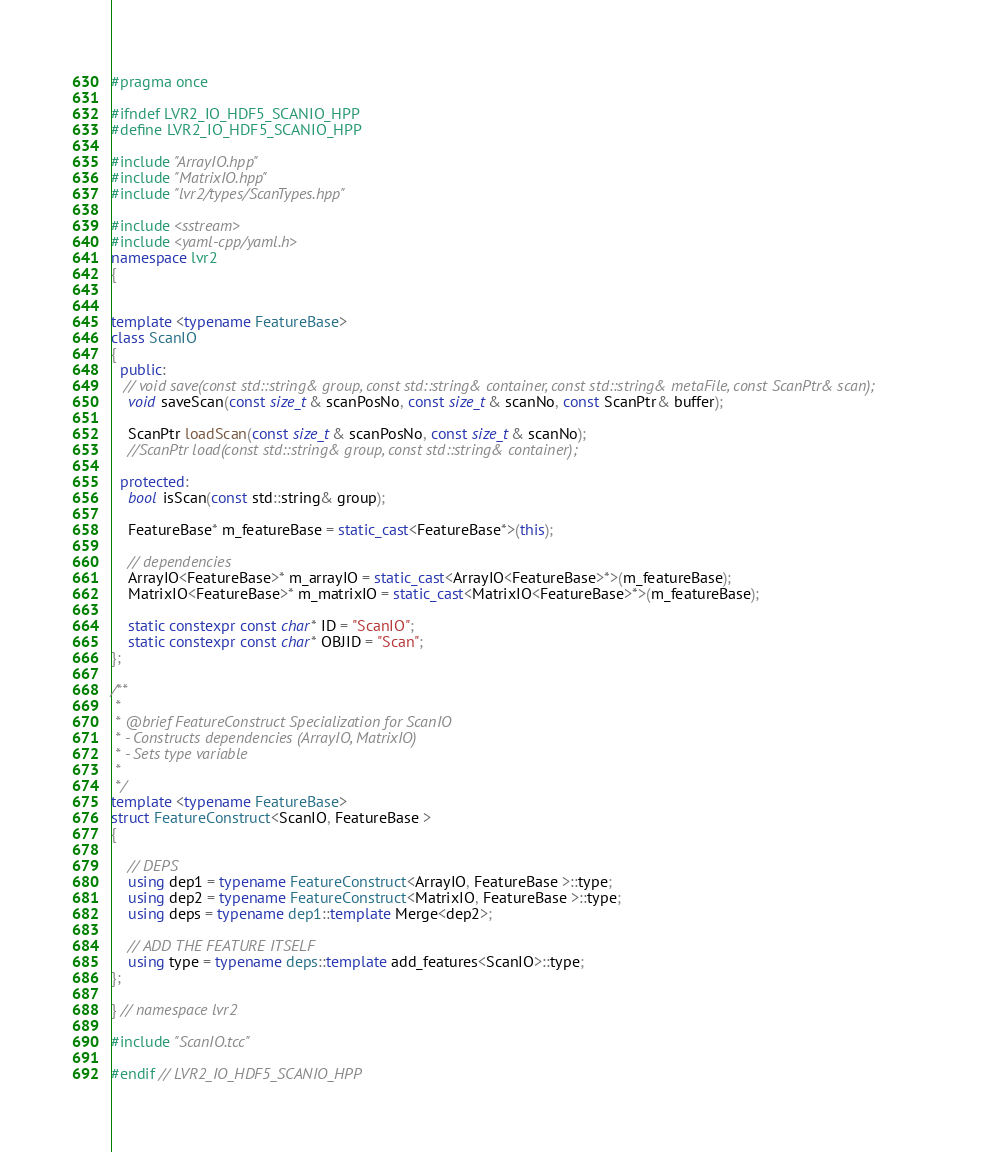<code> <loc_0><loc_0><loc_500><loc_500><_C++_>#pragma once

#ifndef LVR2_IO_HDF5_SCANIO_HPP
#define LVR2_IO_HDF5_SCANIO_HPP

#include "ArrayIO.hpp"
#include "MatrixIO.hpp"
#include "lvr2/types/ScanTypes.hpp"

#include <sstream>
#include <yaml-cpp/yaml.h>
namespace lvr2
{


template <typename FeatureBase>
class ScanIO
{
  public:
   // void save(const std::string& group, const std::string& container, const std::string& metaFile, const ScanPtr& scan);
    void saveScan(const size_t& scanPosNo, const size_t& scanNo, const ScanPtr& buffer);
  
    ScanPtr loadScan(const size_t& scanPosNo, const size_t& scanNo);
    //ScanPtr load(const std::string& group, const std::string& container);
    
  protected:
    bool isScan(const std::string& group);

    FeatureBase* m_featureBase = static_cast<FeatureBase*>(this);

    // dependencies
    ArrayIO<FeatureBase>* m_arrayIO = static_cast<ArrayIO<FeatureBase>*>(m_featureBase);
    MatrixIO<FeatureBase>* m_matrixIO = static_cast<MatrixIO<FeatureBase>*>(m_featureBase);

    static constexpr const char* ID = "ScanIO";
    static constexpr const char* OBJID = "Scan";
};

/**
 *
 * @brief FeatureConstruct Specialization for ScanIO
 * - Constructs dependencies (ArrayIO, MatrixIO)
 * - Sets type variable
 *
 */
template <typename FeatureBase>
struct FeatureConstruct<ScanIO, FeatureBase >
{

    // DEPS
    using dep1 = typename FeatureConstruct<ArrayIO, FeatureBase >::type;
    using dep2 = typename FeatureConstruct<MatrixIO, FeatureBase >::type;
    using deps = typename dep1::template Merge<dep2>;

    // ADD THE FEATURE ITSELF
    using type = typename deps::template add_features<ScanIO>::type;
};

} // namespace lvr2

#include "ScanIO.tcc"

#endif // LVR2_IO_HDF5_SCANIO_HPP
</code> 